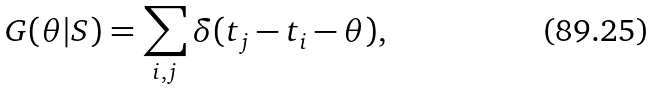Convert formula to latex. <formula><loc_0><loc_0><loc_500><loc_500>G ( \theta | S ) = \sum _ { i , j } \delta ( t _ { j } - t _ { i } - \theta ) ,</formula> 